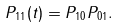Convert formula to latex. <formula><loc_0><loc_0><loc_500><loc_500>P _ { 1 1 } ( t ) = P _ { 1 0 } P _ { 0 1 } .</formula> 